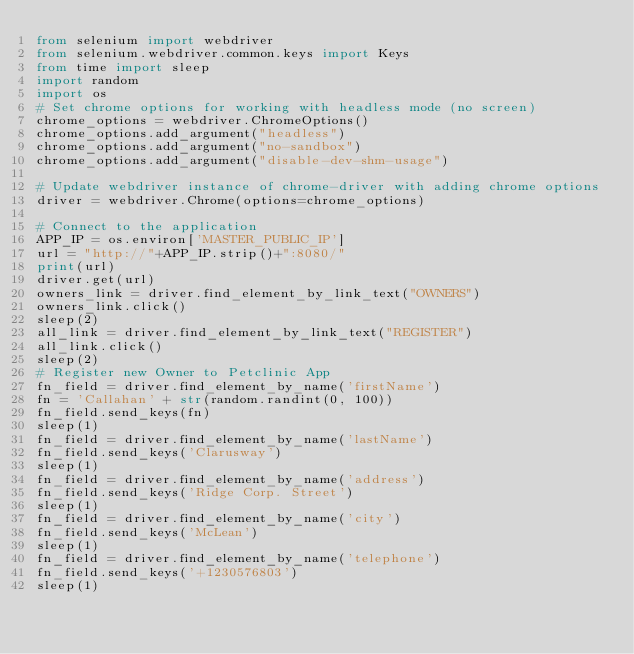<code> <loc_0><loc_0><loc_500><loc_500><_Python_>from selenium import webdriver
from selenium.webdriver.common.keys import Keys
from time import sleep
import random
import os
# Set chrome options for working with headless mode (no screen)
chrome_options = webdriver.ChromeOptions()
chrome_options.add_argument("headless")
chrome_options.add_argument("no-sandbox")
chrome_options.add_argument("disable-dev-shm-usage")

# Update webdriver instance of chrome-driver with adding chrome options
driver = webdriver.Chrome(options=chrome_options)

# Connect to the application
APP_IP = os.environ['MASTER_PUBLIC_IP']
url = "http://"+APP_IP.strip()+":8080/"
print(url)
driver.get(url)
owners_link = driver.find_element_by_link_text("OWNERS")
owners_link.click()
sleep(2)
all_link = driver.find_element_by_link_text("REGISTER")
all_link.click()
sleep(2)
# Register new Owner to Petclinic App
fn_field = driver.find_element_by_name('firstName')
fn = 'Callahan' + str(random.randint(0, 100))
fn_field.send_keys(fn)
sleep(1)
fn_field = driver.find_element_by_name('lastName')
fn_field.send_keys('Clarusway')
sleep(1)
fn_field = driver.find_element_by_name('address')
fn_field.send_keys('Ridge Corp. Street')
sleep(1)
fn_field = driver.find_element_by_name('city')
fn_field.send_keys('McLean')
sleep(1)
fn_field = driver.find_element_by_name('telephone')
fn_field.send_keys('+1230576803')
sleep(1)</code> 